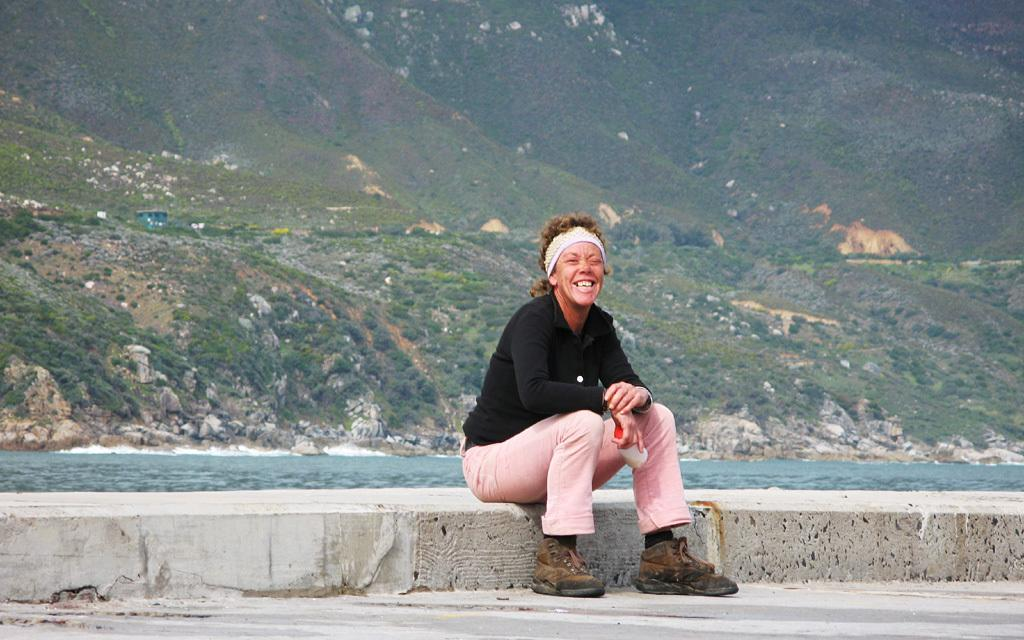What is the person in the image doing? The person is holding an object and sitting on a platform. What is the person's facial expression in the image? The person is smiling. What can be seen in the background of the image? There are mountains visible in the background of the image. What other elements are present in the image besides the person? There are rocks, plants, and an object being held by the person. What type of beetle can be seen attempting to climb the mountain in the image? There is no beetle present in the image, and no attempt to climb the mountain is depicted. What type of oatmeal is being served on the platform in the image? There is no oatmeal present in the image; the person is holding an unspecified object. 